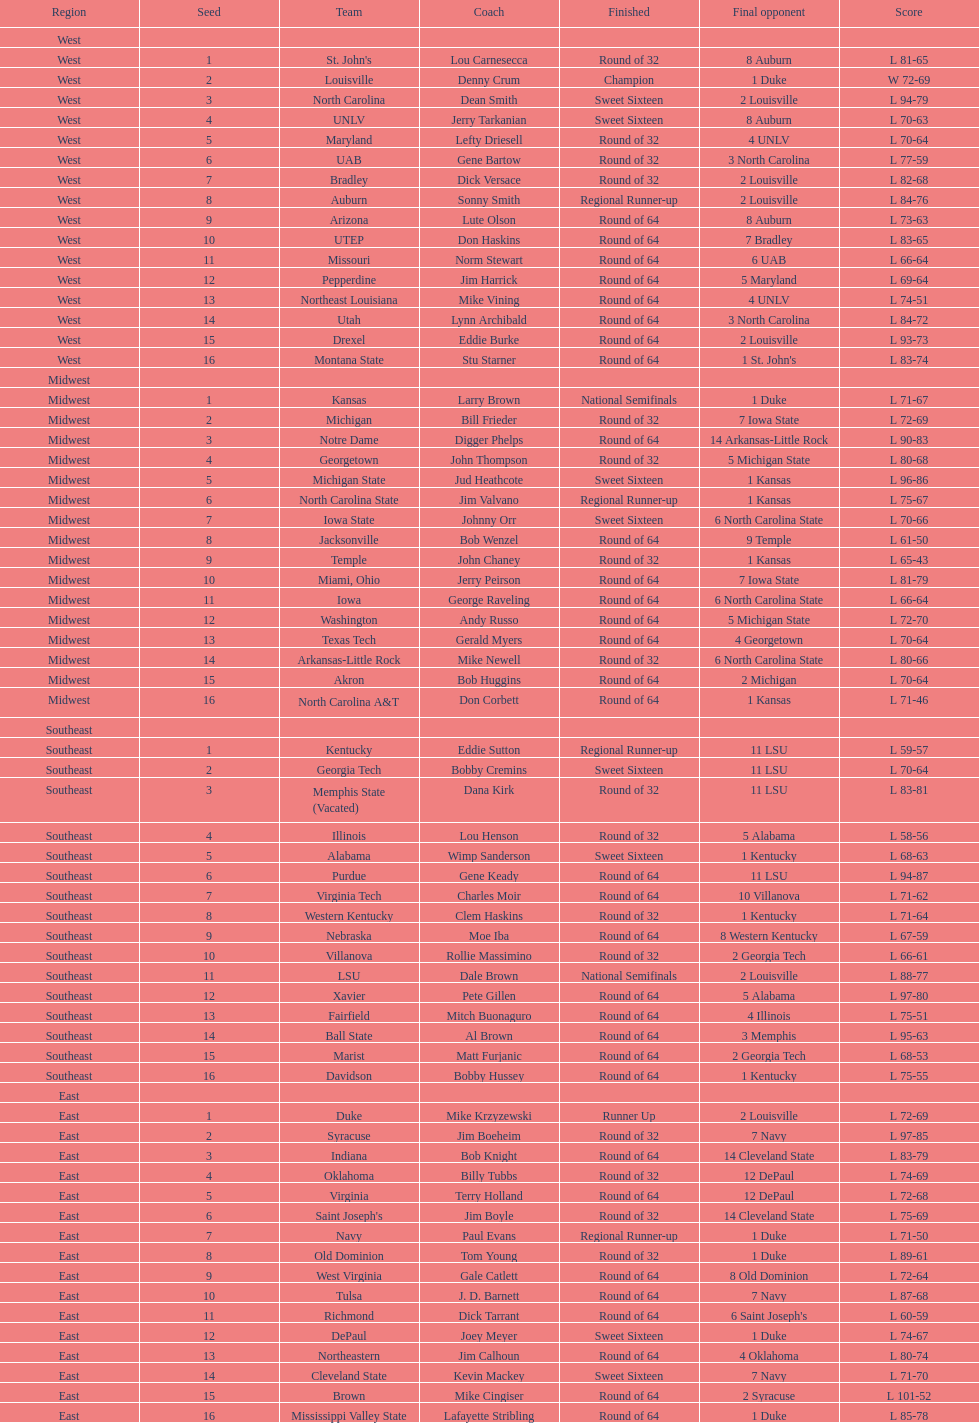How many 1 seeds are there? 4. 